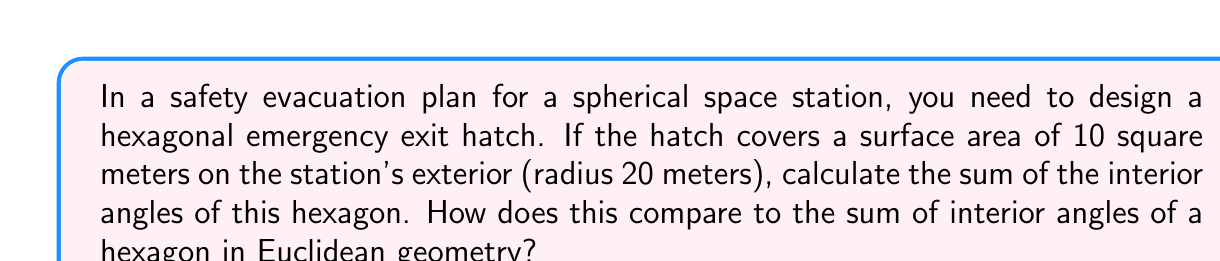Give your solution to this math problem. Let's approach this step-by-step:

1) In spherical geometry, the sum of interior angles of a polygon is given by:

   $$(n-2)\pi + A\frac{4\pi}{4\pi r^2}$$

   Where $n$ is the number of sides, $A$ is the area of the polygon, and $r$ is the radius of the sphere.

2) We have:
   $n = 6$ (hexagon)
   $A = 10$ m²
   $r = 20$ m

3) Substituting these values:

   $$(6-2)\pi + 10\frac{4\pi}{4\pi (20)^2}$$

4) Simplify:

   $$4\pi + 10\frac{\pi}{400} = 4\pi + \frac{\pi}{40}$$

5) Calculate:

   $$4\pi + \frac{\pi}{40} = \frac{160\pi + \pi}{40} = \frac{161\pi}{40} \approx 12.64$$

6) Convert to degrees:

   $$\frac{161\pi}{40} \cdot \frac{180°}{\pi} \approx 724.5°$$

7) In Euclidean geometry, the sum of interior angles of a hexagon is always:

   $$(n-2) \cdot 180° = (6-2) \cdot 180° = 720°$$

8) The difference is:

   $$724.5° - 720° = 4.5°$$

This extra 4.5° is due to the curvature of the spherical surface.
Answer: 724.5°, 4.5° more than a Euclidean hexagon 